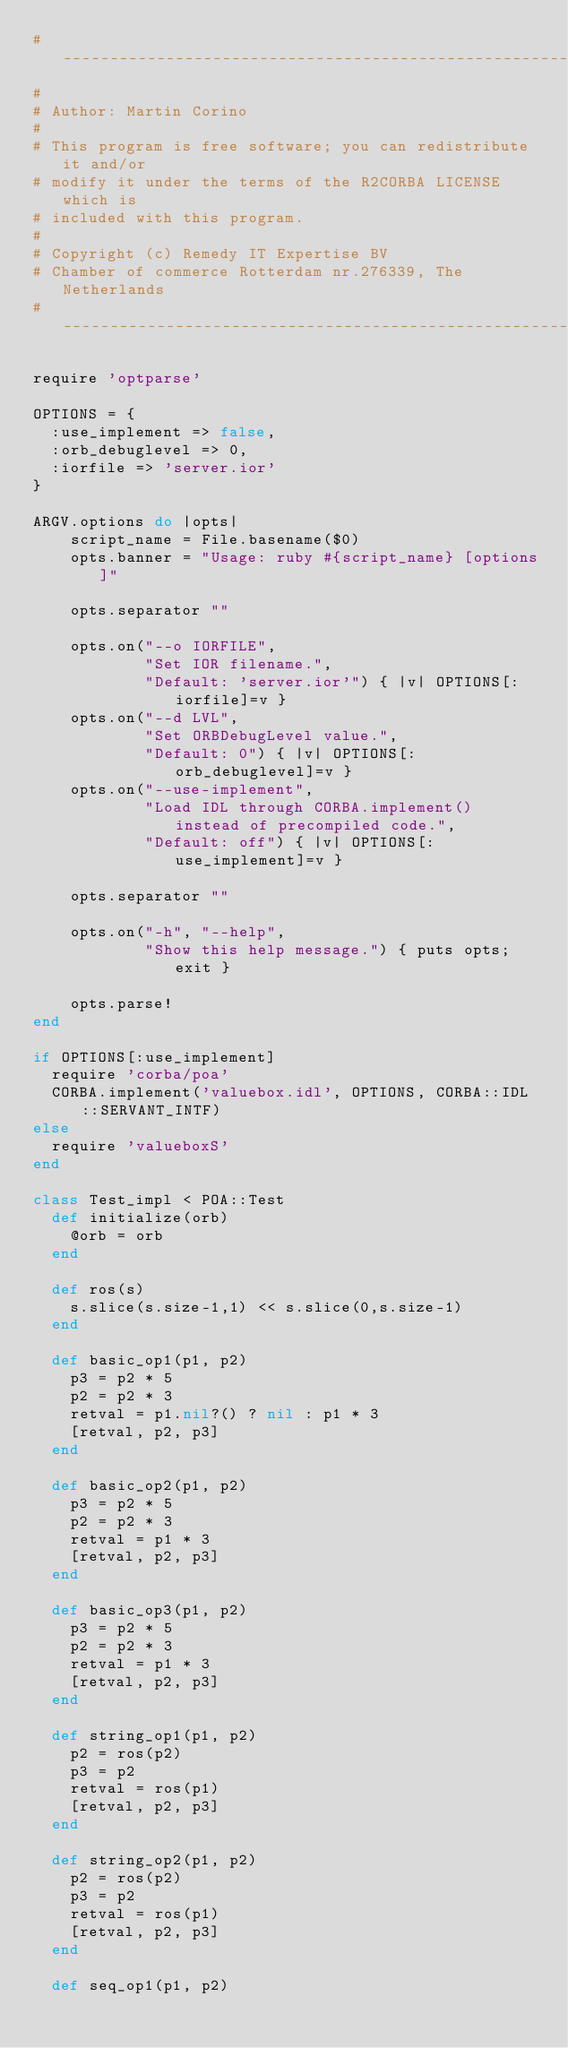<code> <loc_0><loc_0><loc_500><loc_500><_Ruby_>#--------------------------------------------------------------------
#
# Author: Martin Corino
#
# This program is free software; you can redistribute it and/or
# modify it under the terms of the R2CORBA LICENSE which is
# included with this program.
#
# Copyright (c) Remedy IT Expertise BV
# Chamber of commerce Rotterdam nr.276339, The Netherlands
#--------------------------------------------------------------------

require 'optparse'

OPTIONS = {
  :use_implement => false,
  :orb_debuglevel => 0,
  :iorfile => 'server.ior'
}

ARGV.options do |opts|
    script_name = File.basename($0)
    opts.banner = "Usage: ruby #{script_name} [options]"

    opts.separator ""

    opts.on("--o IORFILE",
            "Set IOR filename.",
            "Default: 'server.ior'") { |v| OPTIONS[:iorfile]=v }
    opts.on("--d LVL",
            "Set ORBDebugLevel value.",
            "Default: 0") { |v| OPTIONS[:orb_debuglevel]=v }
    opts.on("--use-implement",
            "Load IDL through CORBA.implement() instead of precompiled code.",
            "Default: off") { |v| OPTIONS[:use_implement]=v }

    opts.separator ""

    opts.on("-h", "--help",
            "Show this help message.") { puts opts; exit }

    opts.parse!
end

if OPTIONS[:use_implement]
  require 'corba/poa'
  CORBA.implement('valuebox.idl', OPTIONS, CORBA::IDL::SERVANT_INTF)
else
  require 'valueboxS'
end

class Test_impl < POA::Test
  def initialize(orb)
    @orb = orb
  end

  def ros(s)
    s.slice(s.size-1,1) << s.slice(0,s.size-1)
  end

  def basic_op1(p1, p2)
    p3 = p2 * 5
    p2 = p2 * 3
    retval = p1.nil?() ? nil : p1 * 3
    [retval, p2, p3]
  end

  def basic_op2(p1, p2)
    p3 = p2 * 5
    p2 = p2 * 3
    retval = p1 * 3
    [retval, p2, p3]
  end

  def basic_op3(p1, p2)
    p3 = p2 * 5
    p2 = p2 * 3
    retval = p1 * 3
    [retval, p2, p3]
  end

  def string_op1(p1, p2)
    p2 = ros(p2)
    p3 = p2
    retval = ros(p1)
    [retval, p2, p3]
  end

  def string_op2(p1, p2)
    p2 = ros(p2)
    p3 = p2
    retval = ros(p1)
    [retval, p2, p3]
  end

  def seq_op1(p1, p2)</code> 